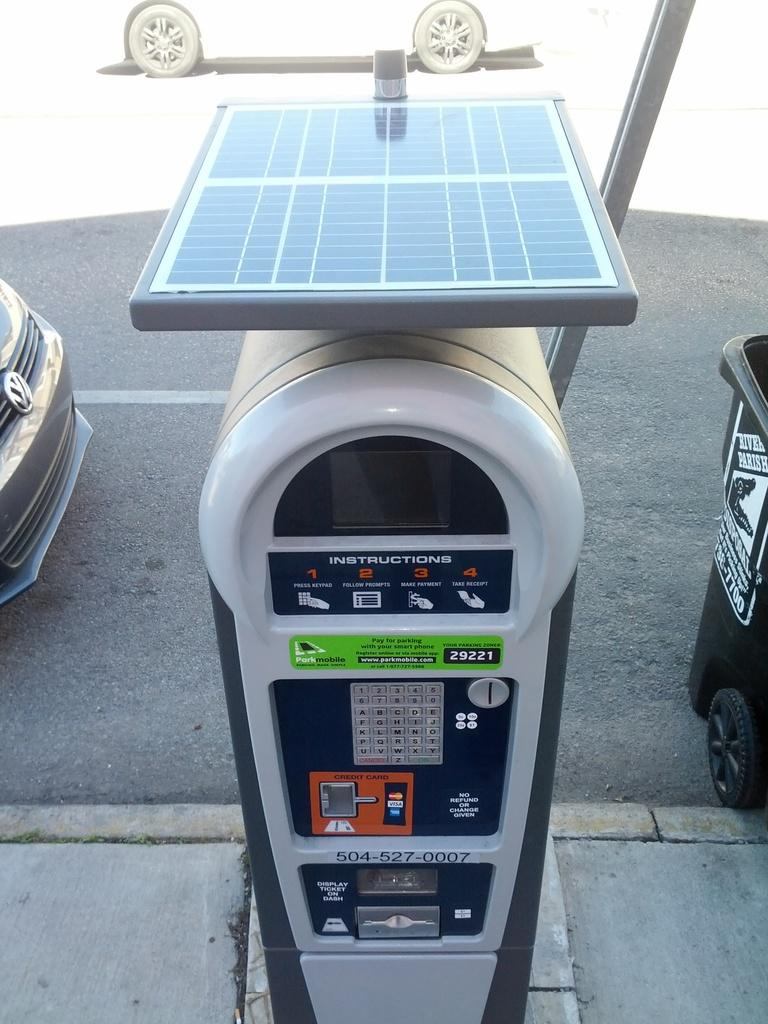What object can be seen on the side of the road in the image? There is a parking meter in the image. What is happening on the road in the image? There are vehicles on the road in the image. Can you describe an object on the right side of the road in the image? There appears to be a dustbin on the right side of the road in the image. What type of joke is being told by the earth in the image? There is no earth or joke present in the image. Can you describe the father's role in the image? There is no father present in the image. 